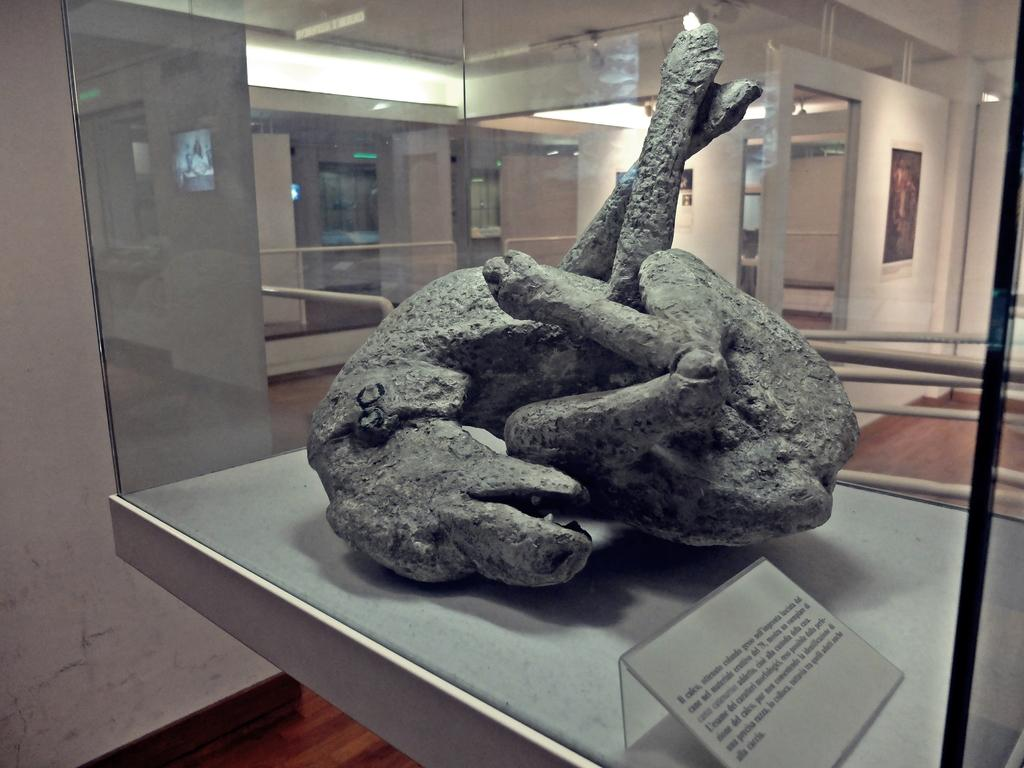What is the main subject of the image? There is an animal sculpture in the image. Where is the animal sculpture located? The animal sculpture is on a glass box. What can be seen in the background of the image? There is a wall and doors visible in the image. Is there any decorative item attached to the wall? Yes, there is a photo frame attached to the wall in the image. What type of market can be seen in the image? There is no market present in the image; it features an animal sculpture on a glass box, a wall, doors, and a photo frame. What is the size of the school in the image? There is no school present in the image. 